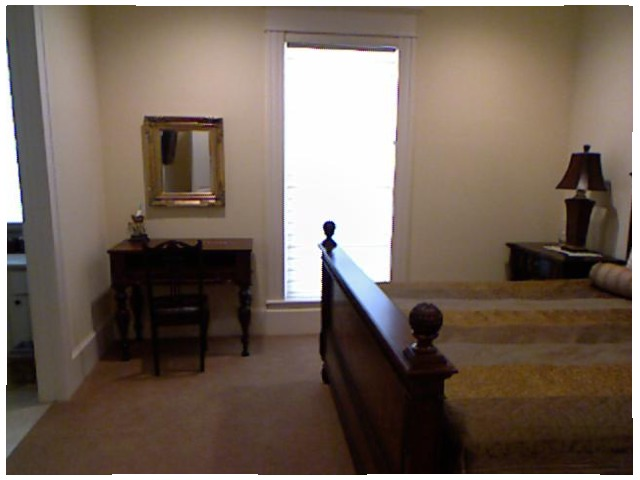<image>
Is there a mirror above the floor? No. The mirror is not positioned above the floor. The vertical arrangement shows a different relationship. Is the lamp above the bed? No. The lamp is not positioned above the bed. The vertical arrangement shows a different relationship. 